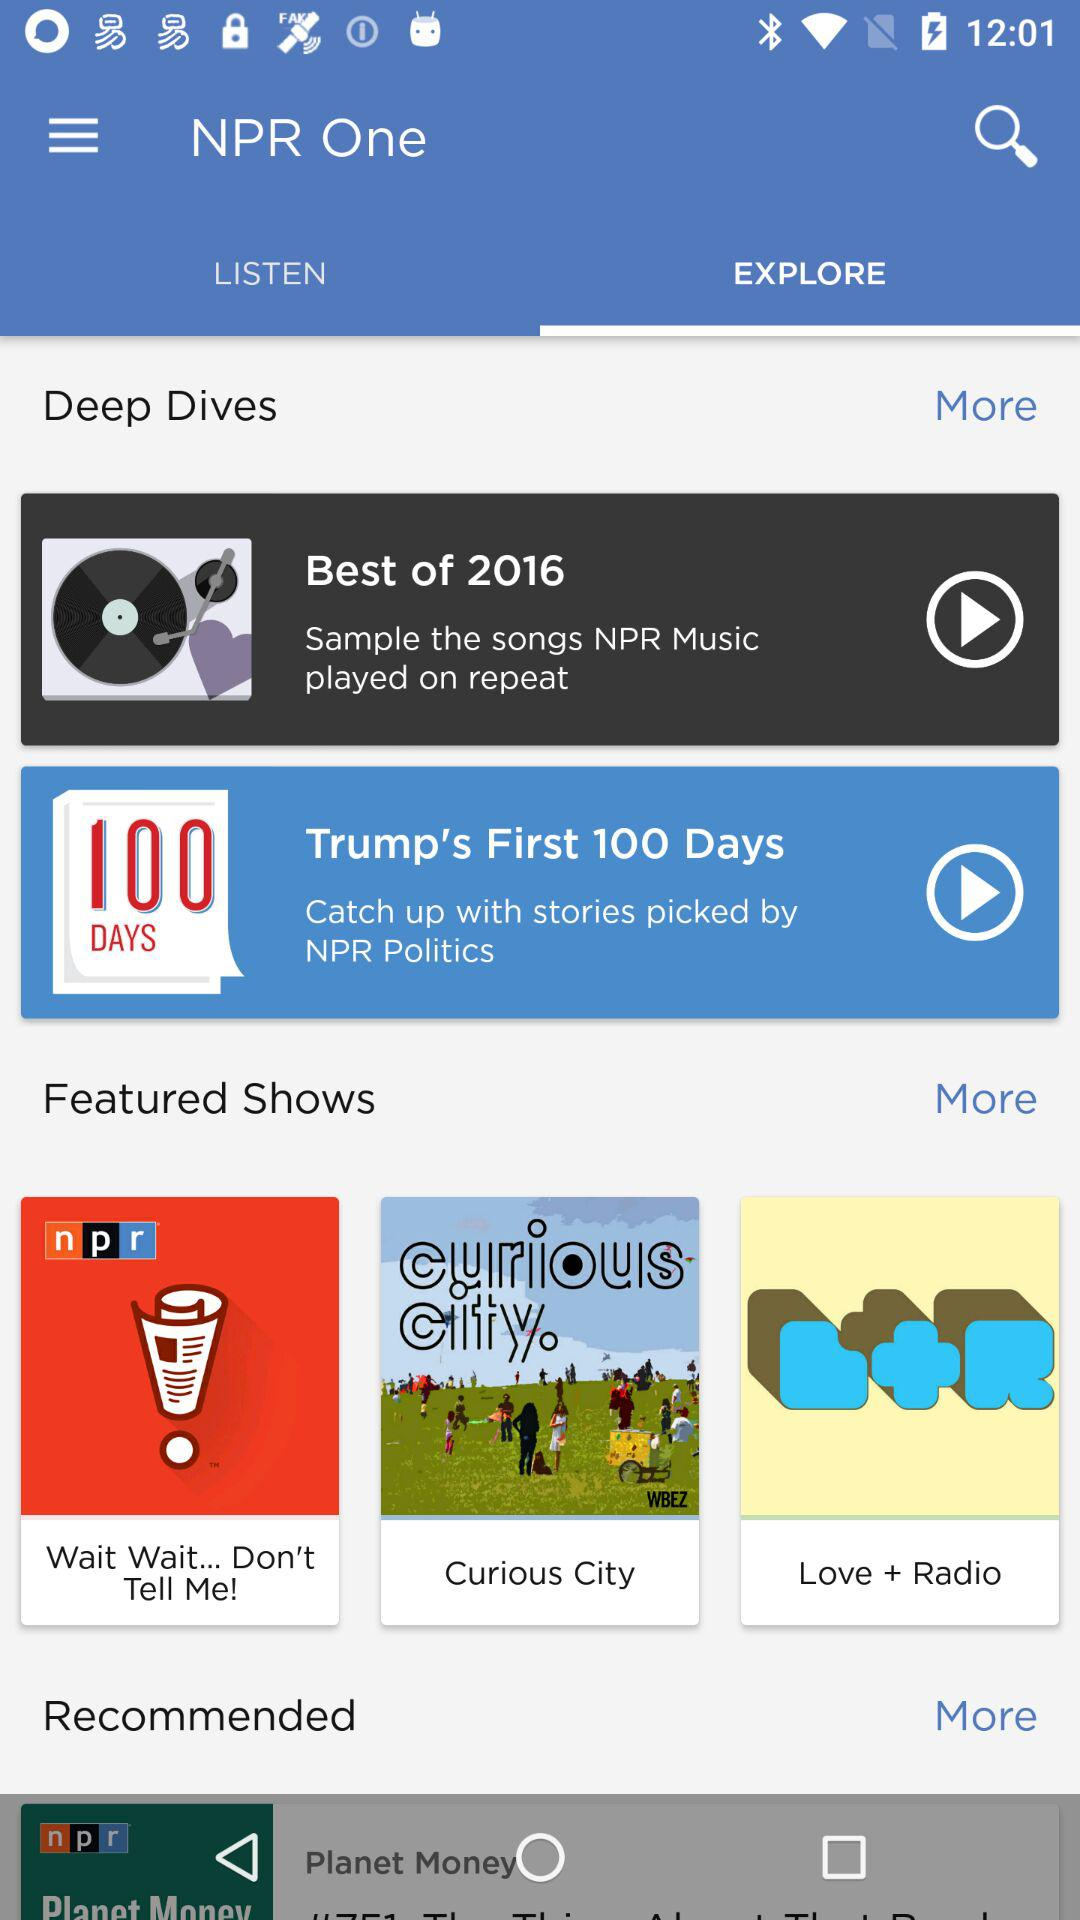Could you name a few of the featured shows?
When the provided information is insufficient, respond with <no answer>. <no answer> 